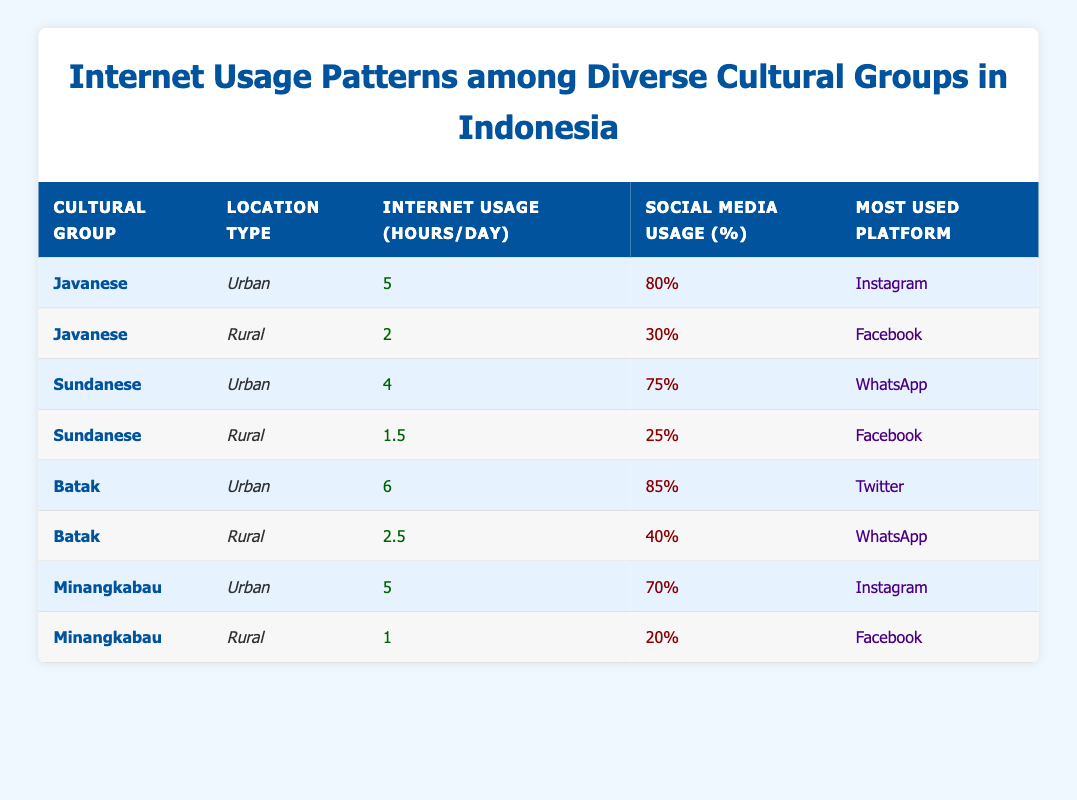What is the most used platform among the Batak people in urban areas? According to the table, the Batak cultural group in urban areas most frequently uses Twitter. This information can be directly retrieved from the row corresponding to the Batak in the urban location type.
Answer: Twitter How many hours do Javanese people use the Internet in rural areas per day? The table specifically states that Javanese people in rural areas use the Internet for 2 hours per day. This can also be found by looking at the row for Javanese with the rural location type.
Answer: 2 What is the average percentage of social media usage for the Sundanese across both urban and rural areas? For the Sundanese, the percentage of social media usage in urban areas is 75% and in rural areas is 25%. The average can be calculated as (75 + 25) / 2 = 50%.
Answer: 50% Which cultural group has the highest Internet usage hours in urban areas? By analyzing the urban rows, the Batak cultural group has the highest Internet usage at 6 hours per day, compared to 5 hours for the Javanese and Minangkabau. This determination comes from directly reading the usage hours listed for each cultural group in urban areas.
Answer: Batak Is it true that all cultural groups in rural areas use Facebook as their most used platform? The rural data shows that all cultural groups (Javanese, Sundanese, Batak, and Minangkabau) do use Facebook in rural areas, which means this statement is true. This can be validated by examining the most used platform for each of those groups in the table's rural section.
Answer: Yes What is the difference in Internet usage hours between Minangkabau in urban and rural areas? The Minangkabau cultural group uses the Internet for 5 hours in urban areas and 1 hour in rural areas. To find the difference, we subtract the rural usage (1 hour) from the urban usage (5 hours), resulting in a difference of 4 hours.
Answer: 4 Which cultural group has the lowest percentage of social media usage in rural areas? Upon reviewing the rural rows, the Minangkabau cultural group has the lowest percentage of social media usage at 20%. This can easily be determined by comparing the percentages of social media use listed for each rural cultural group.
Answer: Minangkabau What is the total percentage of social media usage among all cultural groups in urban areas? The percentages of social media usage for urban areas are 80% (Javanese), 75% (Sundanese), 85% (Batak), and 70% (Minangkabau). To find the total, we add these percentages together: 80 + 75 + 85 + 70 = 310%. To find the average percentage, we divide by the number of groups (4), resulting in 310 / 4 = 77.5%.
Answer: 77.5% 